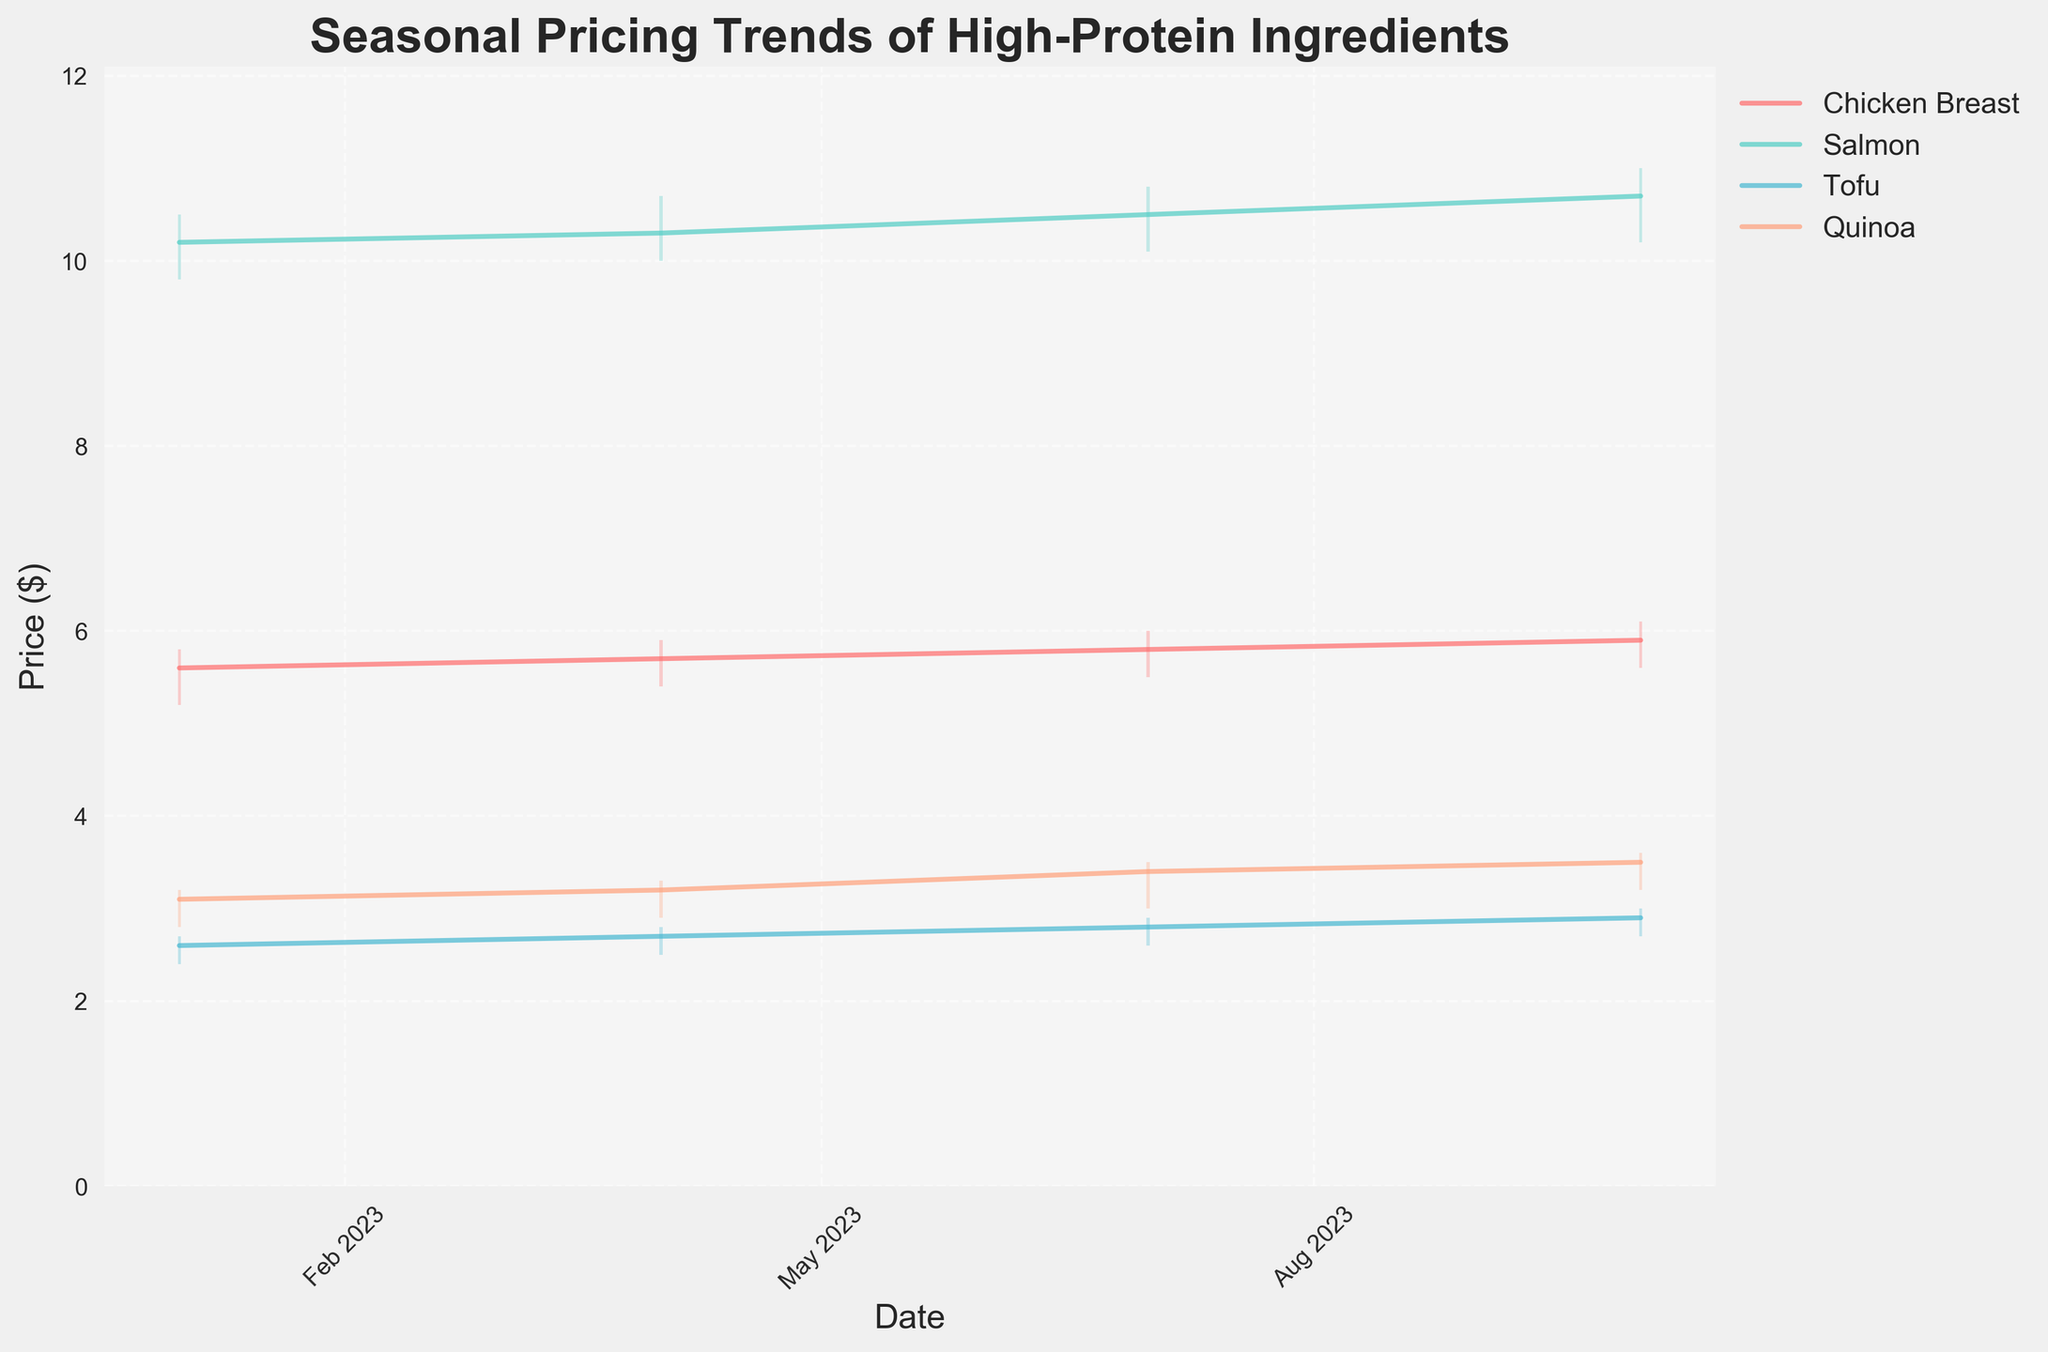What is the title of the figure? The title is found at the top of the figure.
Answer: Seasonal Pricing Trends of High-Protein Ingredients What are the high and low prices of Chicken Breast on April 1, 2023? Identify the high and low values from the corresponding candlestick for Chicken Breast on April 1, 2023.
Answer: High: $5.90, Low: $5.40 Which ingredient shows the highest price trend in October 2023? By looking at the highest points on the y-axis for each ingredient in October, identify the one with the maximum value.
Answer: Salmon What is the average closing price of Quinoa across all the dates? Sum the closing prices of Quinoa and then divide by the number of data points (4). Calculation: (3.10 + 3.20 + 3.40 + 3.50) / 4 = 3.3
Answer: $3.3 How does the price trend of Tofu change from January to October 2023? Observe the closing prices for Tofu from January, April, July, and October to determine the trend. January: $2.60, April: $2.70, July: $2.80, October: $2.90.
Answer: It increases Which ingredient had the most significant price increase from July to October 2023? Calculate the difference in closing prices between July and October for each ingredient and find the maximum value. Chicken Breast: $5.90 - $5.80 = $0.10, Salmon: $10.70 - $10.50 = $0.20, Tofu: $2.90 - $2.80 = $0.10, Quinoa: $3.50 - $3.40 = $0.10
Answer: Salmon Between which two dates did the price of Chicken Breast have the smallest change? Calculate the difference in closing prices between consecutive dates for Chicken Breast and identify the smallest change. Jan-Apr: $5.60 - $5.70 = -$0.10, Apr-Jul: $5.70 - $5.80 = -$0.10, Jul-Oct: $5.80 - $5.90 = -$0.10
Answer: January to April What pattern do you see in the price trends of high-protein ingredients throughout the year? Observe the overall trend lines of each ingredient's closing prices throughout the year and identify any patterns. Most ingredients show a general upward trend from January to October.
Answer: Upward trend How many times do the prices of Salmon increase throughout the year 2023? Count the number of times the closing prices of Salmon increase from one period to the next. Prices: January: $10.20, April: $10.30, July: $10.50, October: $10.70. They increase three times (Jan-Apr, Apr-Jul, Jul-Oct)
Answer: 3 